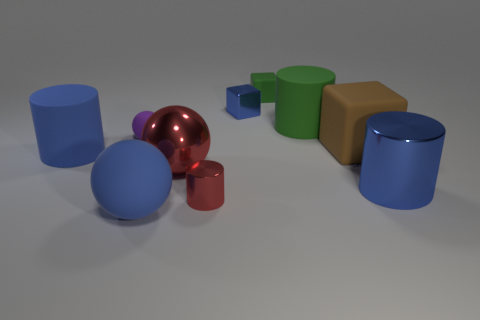Subtract 1 cylinders. How many cylinders are left? 3 Subtract all cubes. How many objects are left? 7 Subtract all red things. Subtract all small matte balls. How many objects are left? 7 Add 3 small red shiny objects. How many small red shiny objects are left? 4 Add 4 blue metallic cylinders. How many blue metallic cylinders exist? 5 Subtract 0 purple cylinders. How many objects are left? 10 